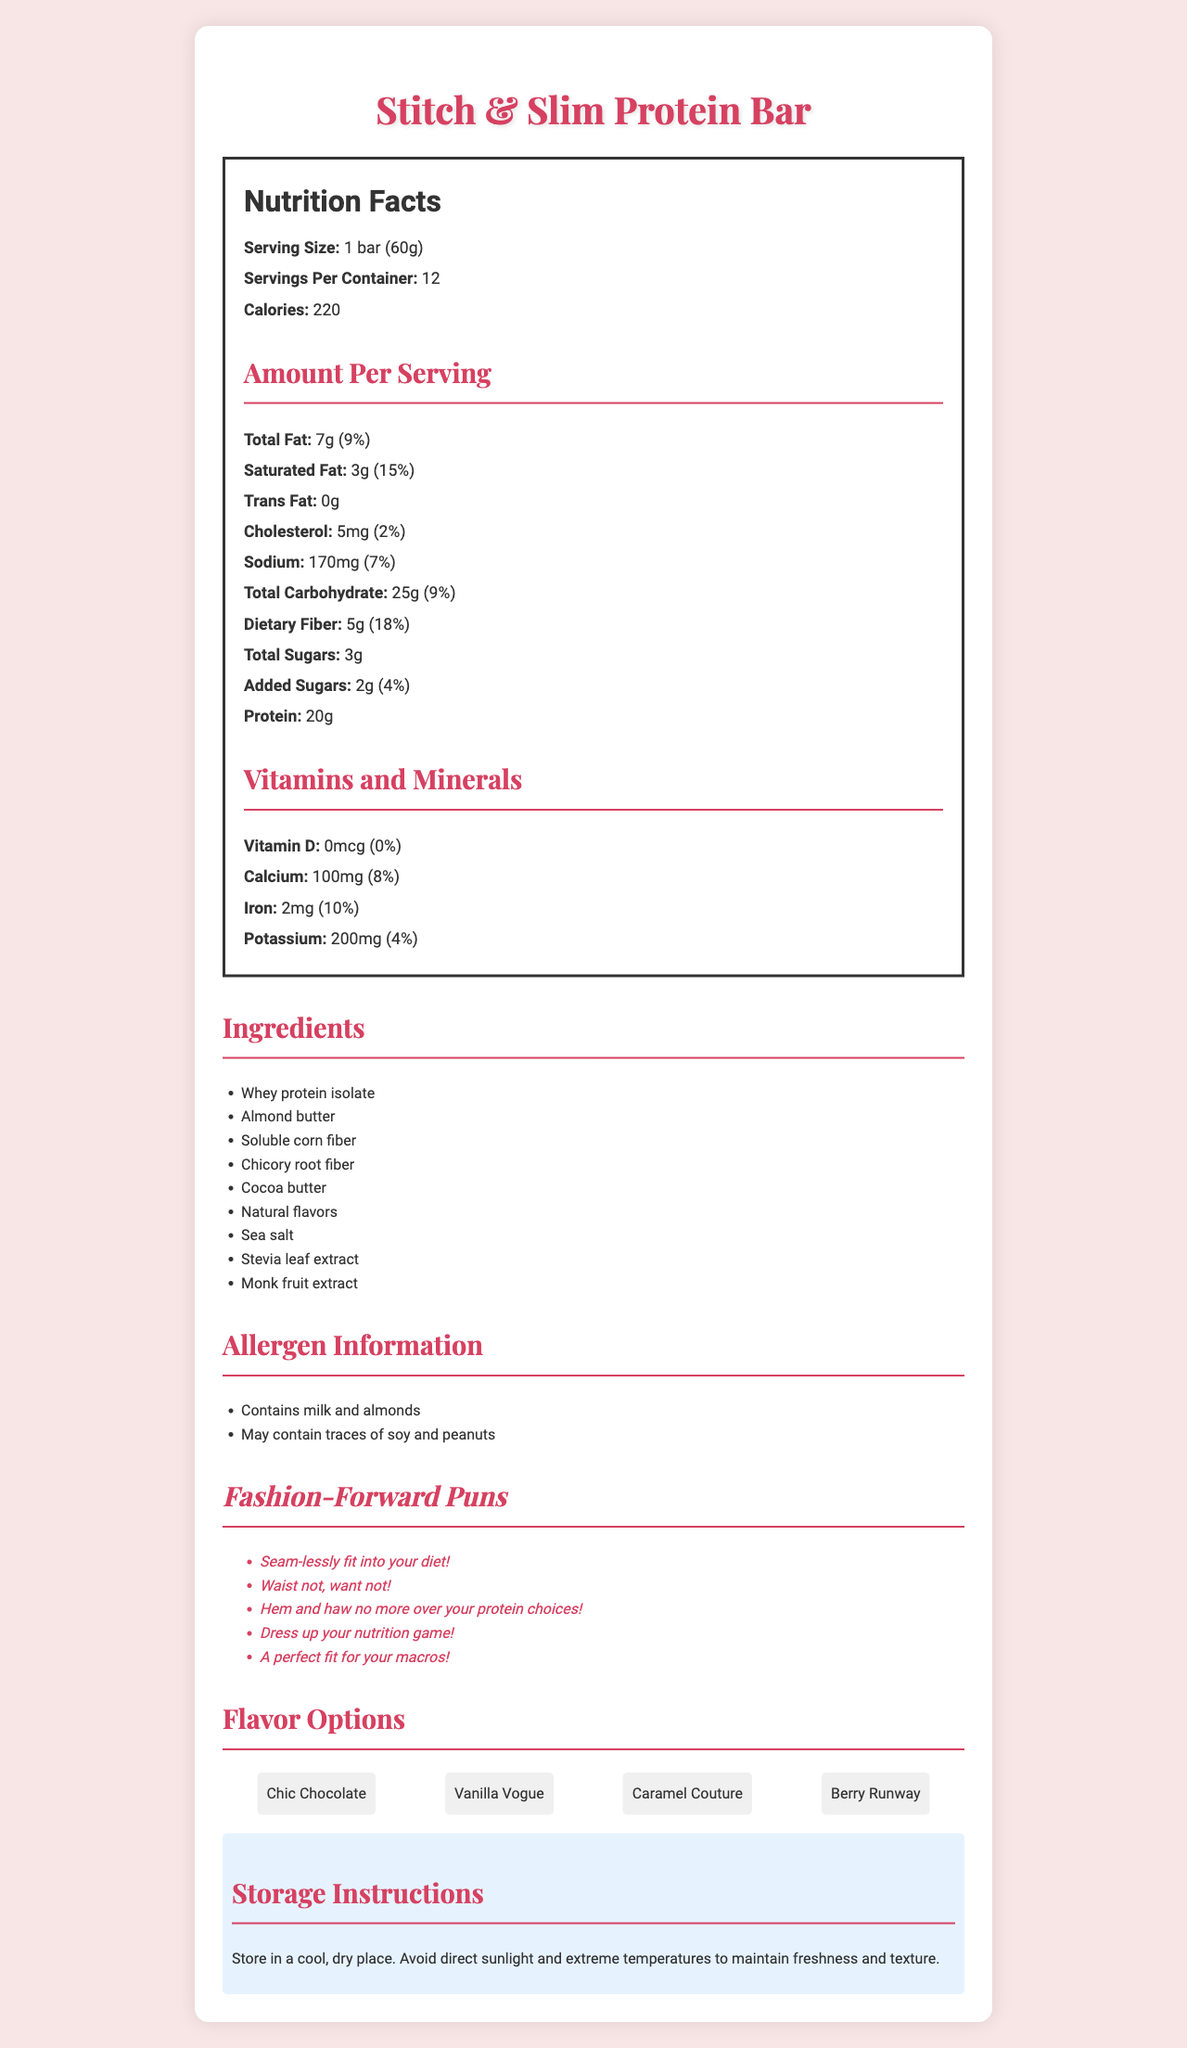what is the serving size of the "Stitch & Slim Protein Bar"? The serving size is listed as "1 bar (60g)" in the Nutrition Facts section of the document.
Answer: 1 bar (60g) how many servings per container are there? The Nutrition Facts state that there are 12 servings per container.
Answer: 12 what is the total fat content per serving? The Nutrition Facts state that the total fat per serving is 7g.
Answer: 7g how many grams of protein are in one serving of the protein bar? The Nutrition Facts state that there are 20g of protein per serving.
Answer: 20g how many grams of dietary fiber does the protein bar contain per serving? The Nutrition Facts section lists 5g of dietary fiber per serving.
Answer: 5g what is the percentage daily value of calcium in the protein bar? The Nutrition Facts state that the daily value of calcium per serving is 8%.
Answer: 8% what allergens does the protein bar contain? The allergen information provided lists these potential allergens.
Answer: Contains milk and almonds, May contain traces of soy and peanuts which of the following is not included in the ingredients of the protein bar? A. Stevia leaf extract B. Coconut oil C. Cocoa butter D. Almond butter Coconut oil is not listed in the ingredients, while Stevia leaf extract, Cocoa butter, and Almond butter are.
Answer: B. Coconut oil what is the correct flavor option for the protein bar? I. Caramel Couture II. Hazelnut Haute III. Berry Runway IV. Vanilla Vogue Hazelnut Haute is not listed as a flavor option, while Caramel Couture, Berry Runway, and Vanilla Vogue are.
Answer: II. Hazelnut Haute are there any vitamins present in the "Stitch & Slim Protein Bar"? The Nutrition Facts state that Vitamin D is present at 0mcg, which is 0% of the daily value, indicating no significant vitamins are present.
Answer: No please summarize the document. The document combines detailed nutritional information with marketing elements like puns and flavor options, emphasizing its fitness benefits and brand personality.
Answer: The document provides detailed information about the "Stitch & Slim Protein Bar", including its nutrition facts, ingredients, allergens, pun taglines, flavor options, and storage instructions. It highlights the bar's macro content with 220 calories, 20g of protein, and various vitamins and minerals. The document also emphasizes the fashion-forward branding and dietary suitability of the bar. what is the cost of one protein bar? The document does not include any information related to the price or cost of the protein bar.
Answer: Cannot be determined 